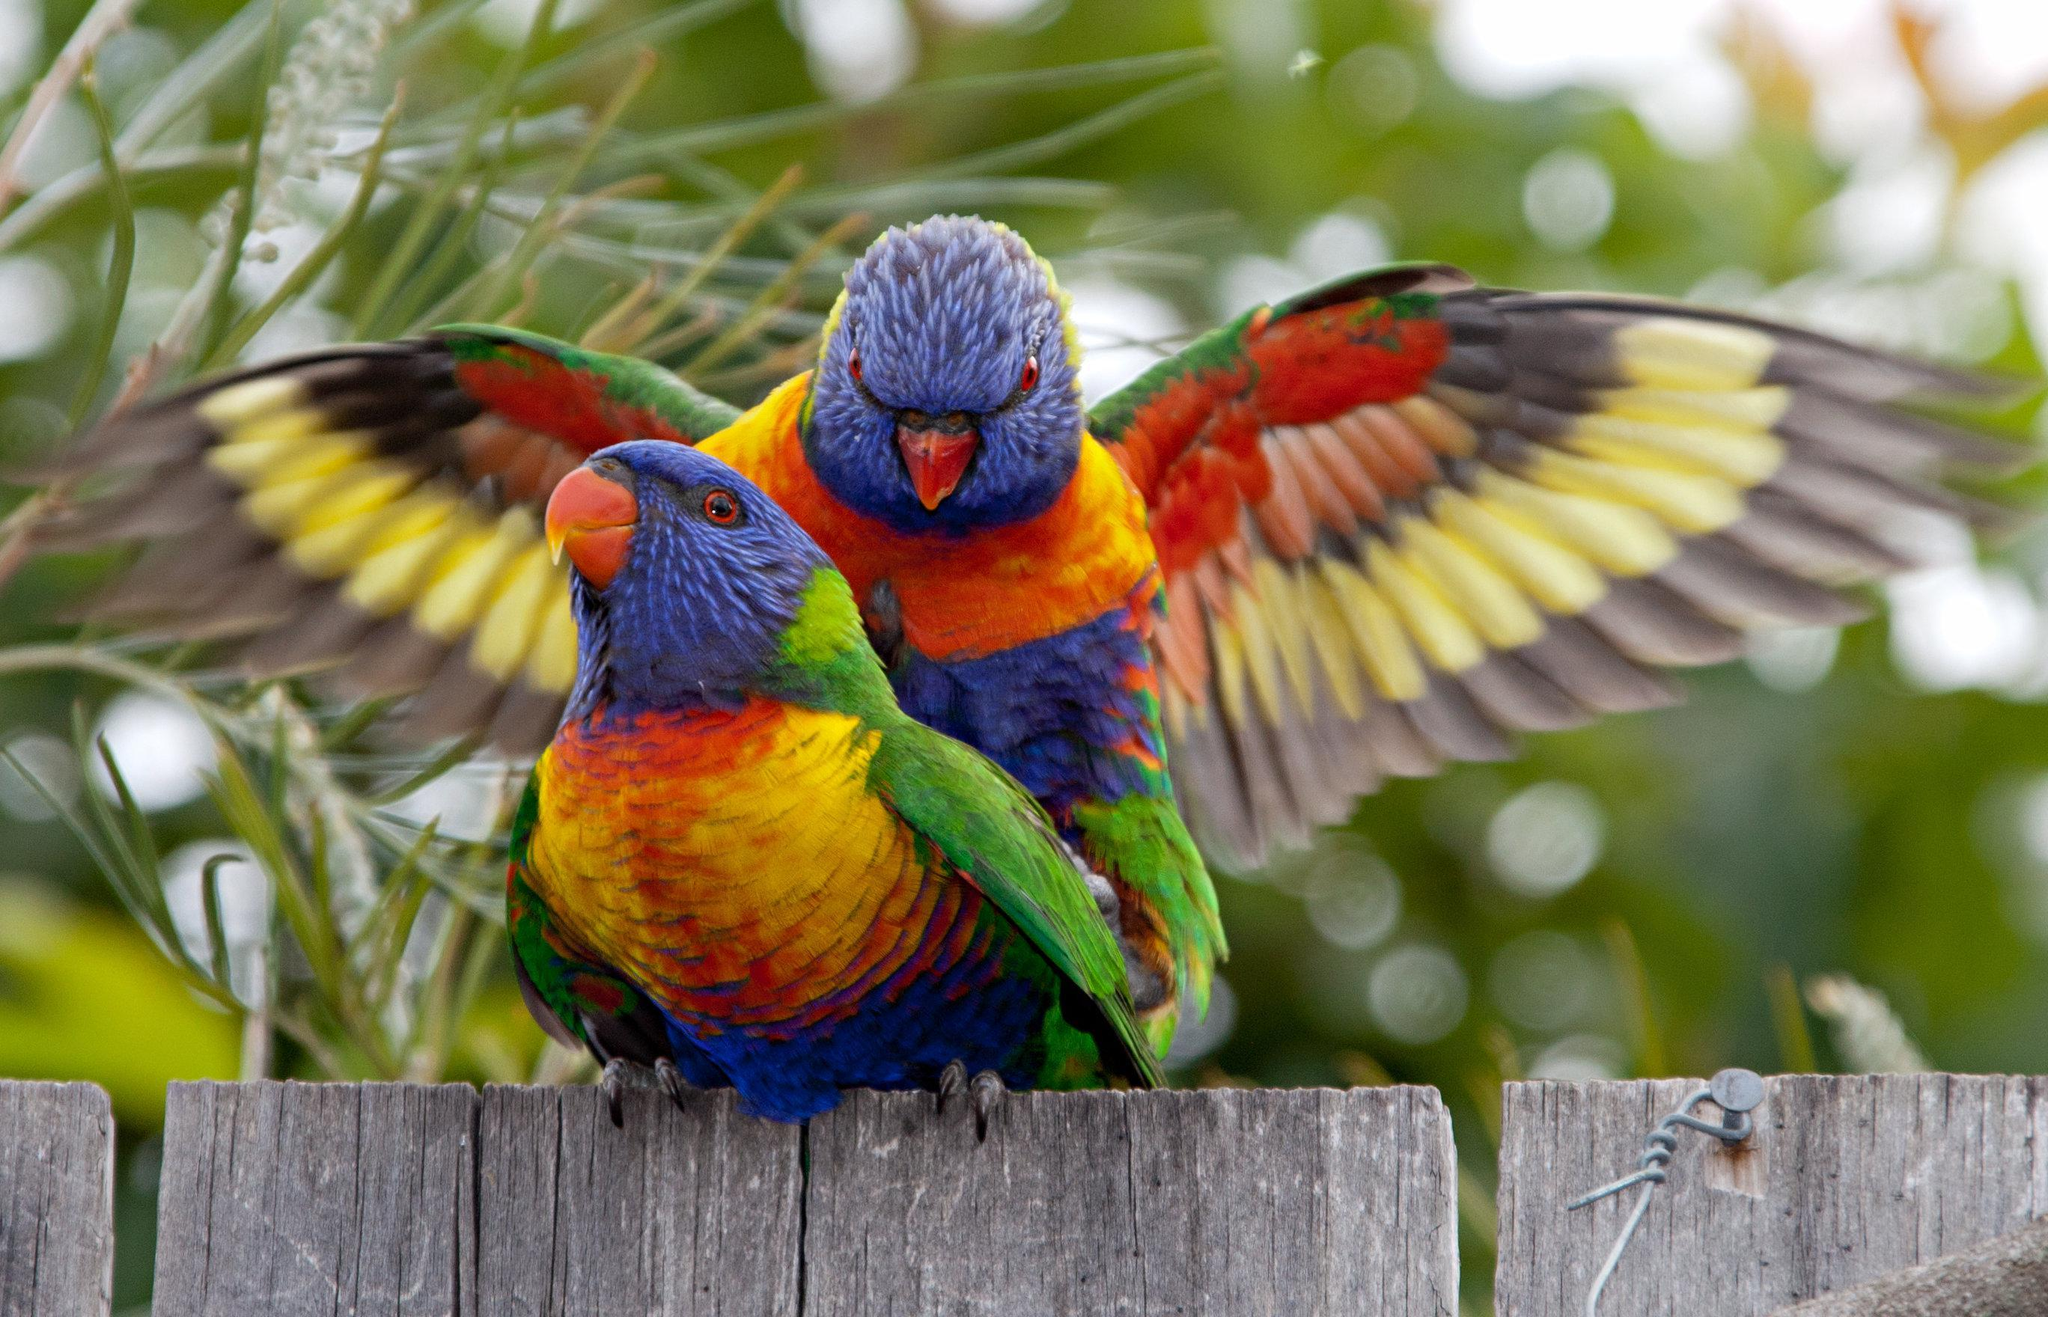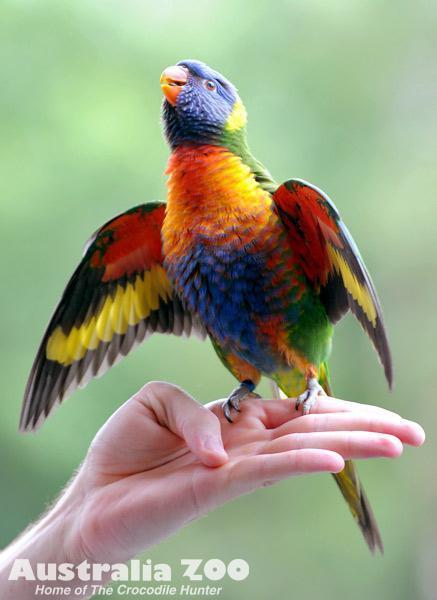The first image is the image on the left, the second image is the image on the right. Given the left and right images, does the statement "At least one parrot is perched on a human hand." hold true? Answer yes or no. Yes. The first image is the image on the left, the second image is the image on the right. Assess this claim about the two images: "The left image contains at least two parrots.". Correct or not? Answer yes or no. Yes. 